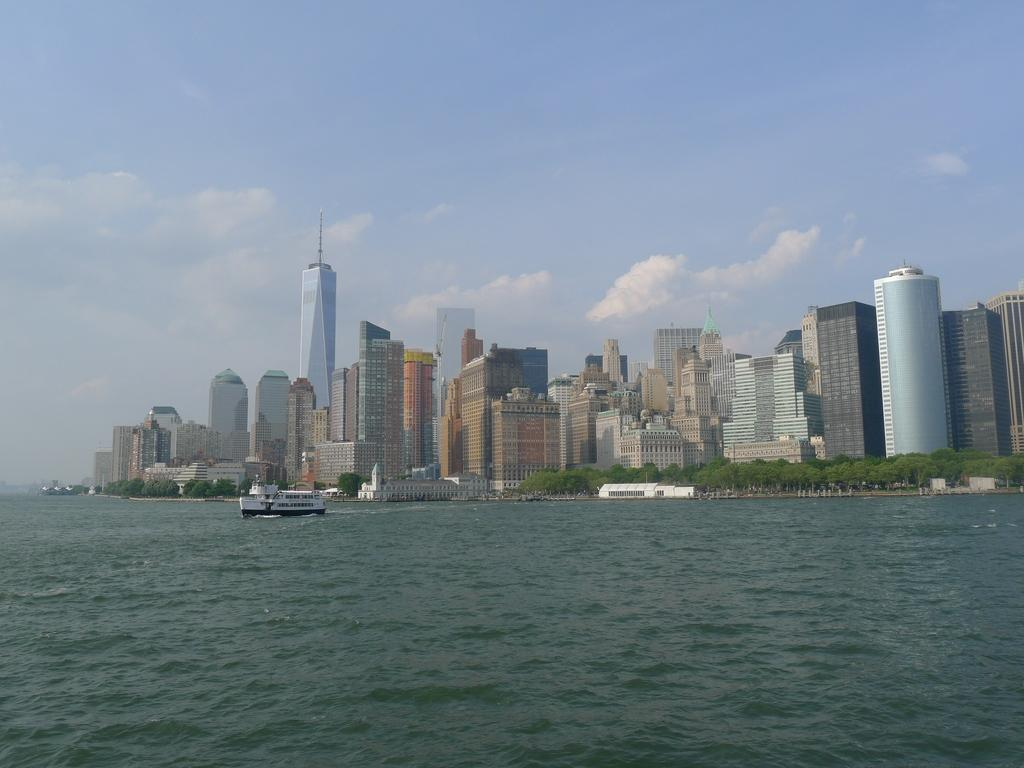What is the main subject of the image? The main subject of the image is a ship. Where is the ship located in the image? The ship is on the water. What can be seen in the background of the image? There are buildings, trees, and clouds in the sky in the background of the image. What type of basket is hanging from the ship's mast in the image? There is no basket hanging from the ship's mast in the image. What kind of hall can be seen in the background of the image? There is no hall present in the image; the background features buildings, trees, and clouds in the sky. 